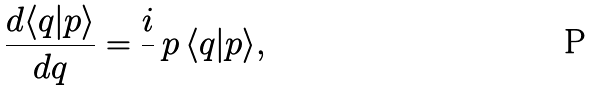<formula> <loc_0><loc_0><loc_500><loc_500>\frac { d \langle q | p \rangle } { d q } = \frac { i } { } \, p \, \langle q | p \rangle ,</formula> 